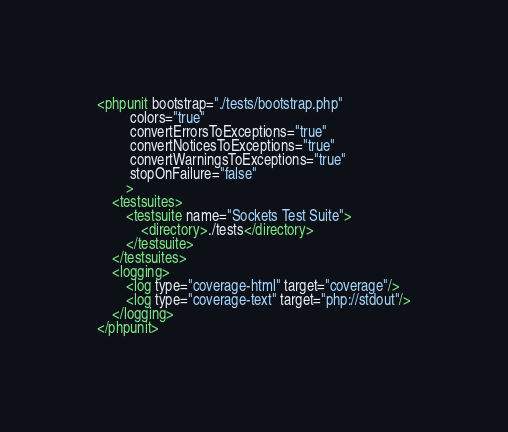<code> <loc_0><loc_0><loc_500><loc_500><_XML_><phpunit bootstrap="./tests/bootstrap.php"
         colors="true"
         convertErrorsToExceptions="true"
         convertNoticesToExceptions="true"
         convertWarningsToExceptions="true"
         stopOnFailure="false"
        >
    <testsuites>
        <testsuite name="Sockets Test Suite">
            <directory>./tests</directory>
        </testsuite>
    </testsuites>
    <logging>
        <log type="coverage-html" target="coverage"/>
        <log type="coverage-text" target="php://stdout"/>
    </logging>
</phpunit>
</code> 